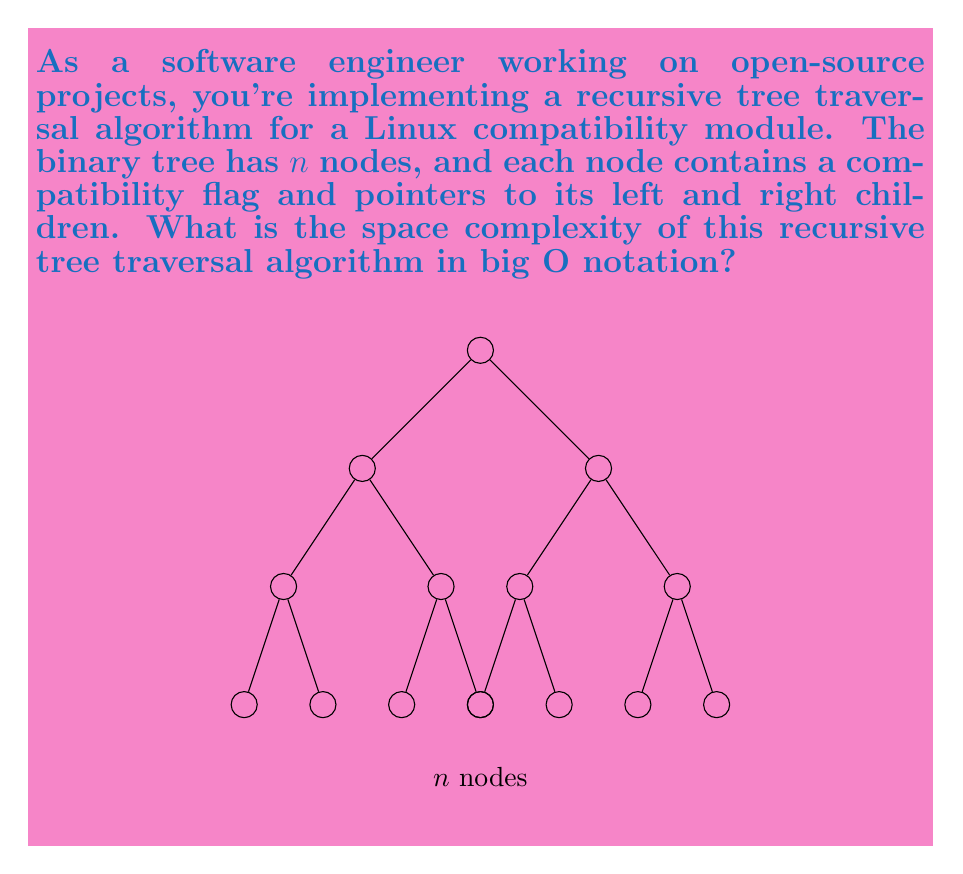Provide a solution to this math problem. To determine the space complexity of a recursive tree traversal algorithm, we need to consider the following factors:

1. Input size: The tree has $n$ nodes.

2. Recursion stack: Each recursive call adds a new frame to the call stack.

3. Depth of recursion: In a binary tree, the maximum depth (or height) is $O(\log n)$ for a balanced tree, and $O(n)$ in the worst case (skewed tree).

4. Space per recursive call: Each call typically uses $O(1)$ extra space for local variables.

Step-by-step analysis:

1. The base case (leaf node) uses $O(1)$ space.

2. For each recursive call, we add $O(1)$ space to the call stack.

3. The maximum number of simultaneous recursive calls is equal to the height of the tree.

4. For a balanced binary tree:
   - Height = $O(\log n)$
   - Space complexity = $O(\log n)$ * $O(1)$ = $O(\log n)$

5. For a skewed binary tree (worst case):
   - Height = $O(n)$
   - Space complexity = $O(n)$ * $O(1)$ = $O(n)$

6. We don't know the exact structure of the tree, so we consider the worst-case scenario.

Therefore, the space complexity of the recursive tree traversal algorithm is $O(n)$ in the worst case.
Answer: $O(n)$ 